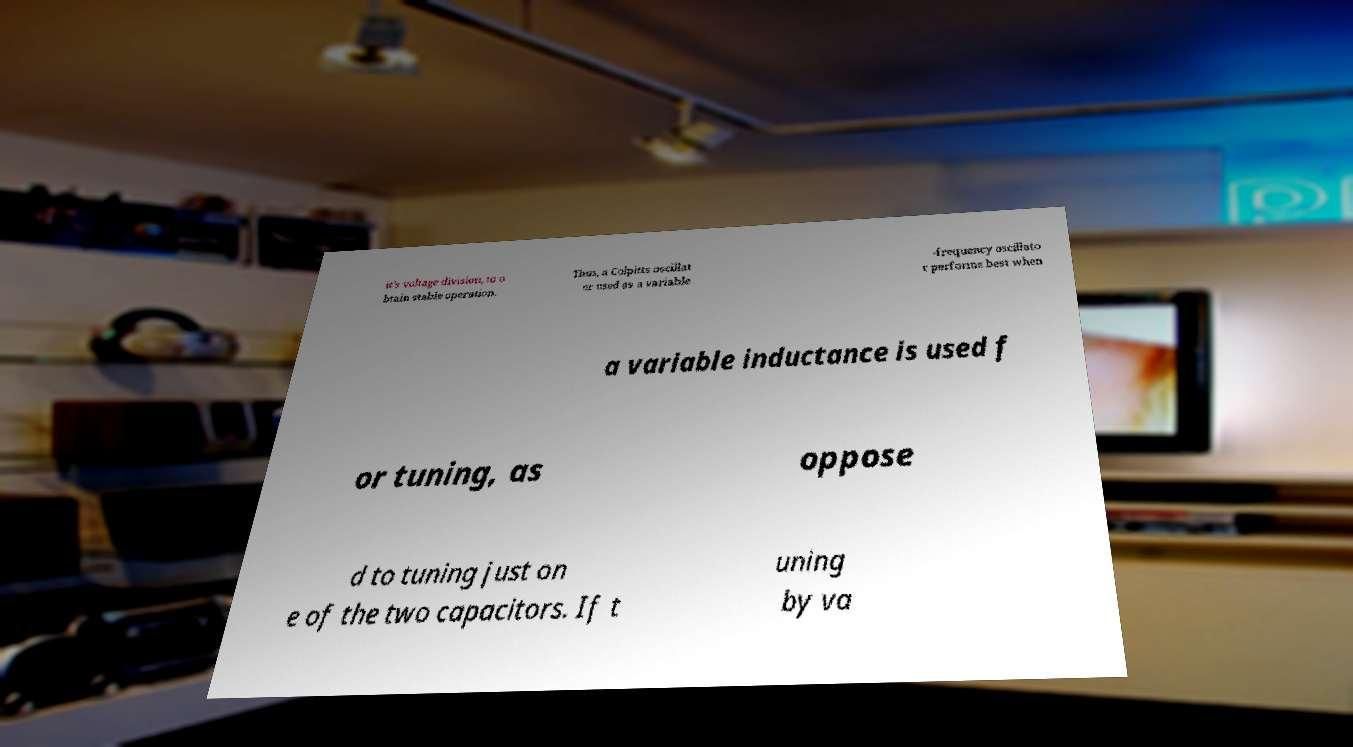For documentation purposes, I need the text within this image transcribed. Could you provide that? it's voltage division, to o btain stable operation. Thus, a Colpitts oscillat or used as a variable -frequency oscillato r performs best when a variable inductance is used f or tuning, as oppose d to tuning just on e of the two capacitors. If t uning by va 